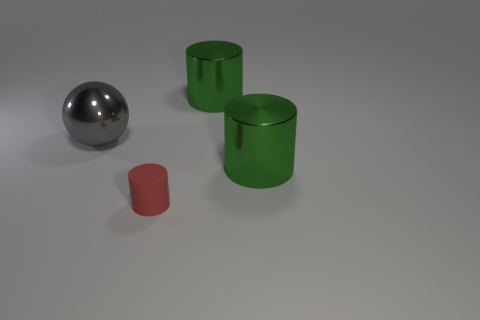There is a metal thing that is left of the small cylinder; is its shape the same as the small red matte thing?
Offer a very short reply. No. What number of metallic objects are the same shape as the red rubber object?
Make the answer very short. 2. Is there another gray object that has the same material as the gray object?
Make the answer very short. No. There is a big cylinder behind the green shiny cylinder in front of the big gray shiny sphere; what is it made of?
Your answer should be compact. Metal. What size is the shiny thing that is on the left side of the matte cylinder?
Make the answer very short. Large. Is the color of the tiny rubber thing the same as the thing on the left side of the tiny object?
Offer a very short reply. No. Is there a large matte thing of the same color as the tiny cylinder?
Make the answer very short. No. Is the material of the small red cylinder the same as the object on the left side of the red cylinder?
Offer a very short reply. No. How many tiny things are rubber objects or brown objects?
Keep it short and to the point. 1. Is the number of tiny yellow metallic spheres less than the number of spheres?
Your answer should be compact. Yes. 